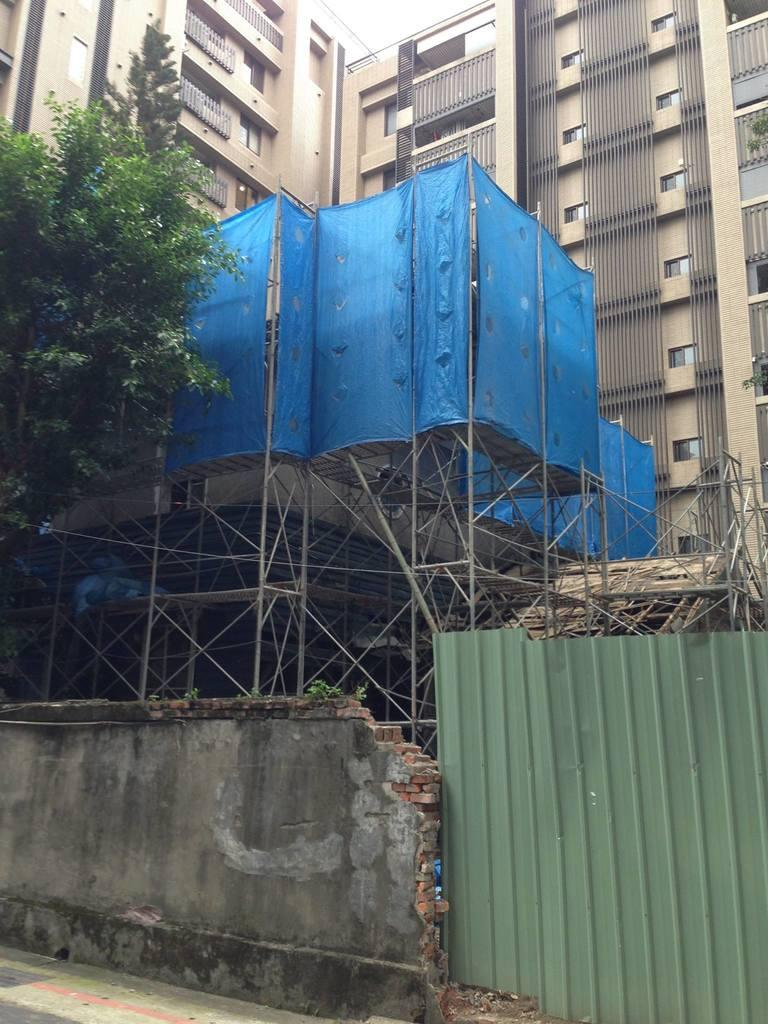What type of structures can be seen in the image? There are buildings in the image. What is covering something in the image? There is a cover visible in the image. Where is the tree located in the image? The tree is on the left side of the image. What is present at the bottom of the image? There is a wall and a sheet at the bottom of the image. Can you see a pig playing baseball in the image? No, there is no pig or baseball present in the image. 